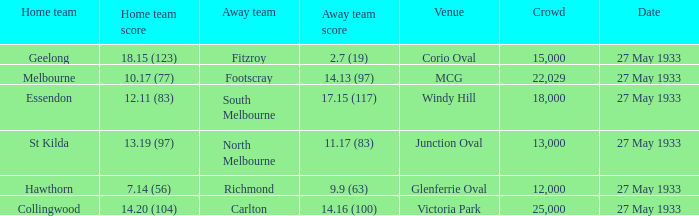What was the size of the crowd during st kilda's home game? 13000.0. 